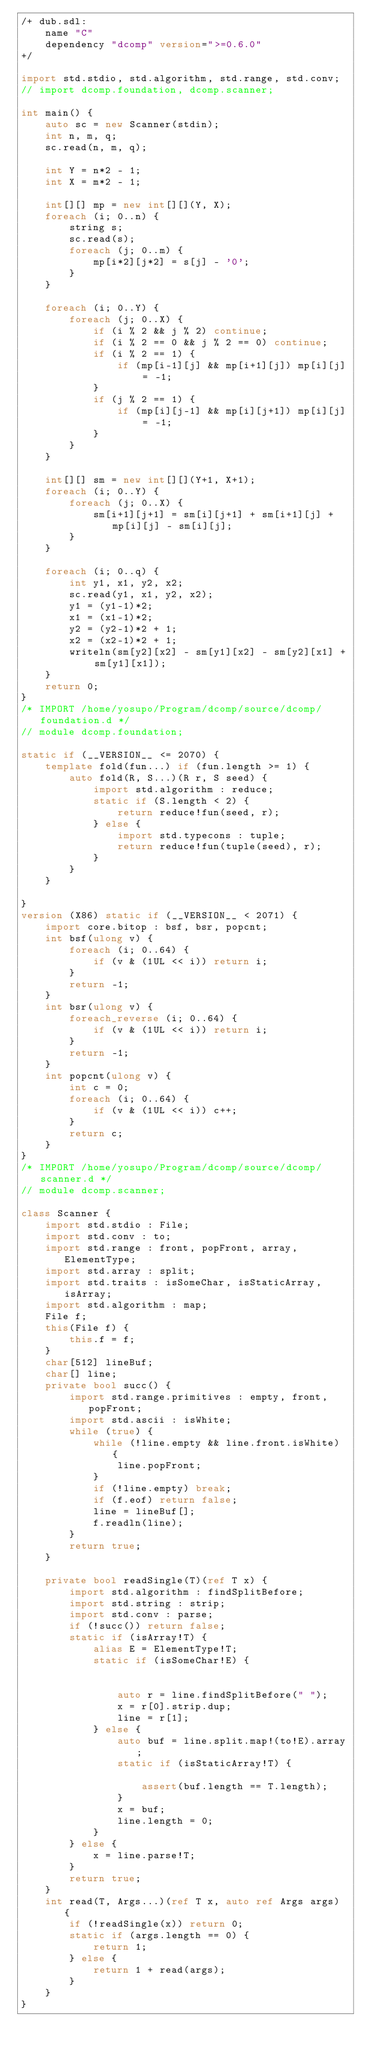<code> <loc_0><loc_0><loc_500><loc_500><_D_>/+ dub.sdl:
    name "C"
    dependency "dcomp" version=">=0.6.0"
+/

import std.stdio, std.algorithm, std.range, std.conv;
// import dcomp.foundation, dcomp.scanner;

int main() {
    auto sc = new Scanner(stdin);
    int n, m, q;
    sc.read(n, m, q);

    int Y = n*2 - 1;
    int X = m*2 - 1;

    int[][] mp = new int[][](Y, X);
    foreach (i; 0..n) {
        string s;
        sc.read(s);
        foreach (j; 0..m) {
            mp[i*2][j*2] = s[j] - '0';
        }
    }

    foreach (i; 0..Y) {
        foreach (j; 0..X) {
            if (i % 2 && j % 2) continue;
            if (i % 2 == 0 && j % 2 == 0) continue;
            if (i % 2 == 1) {
                if (mp[i-1][j] && mp[i+1][j]) mp[i][j] = -1;
            }
            if (j % 2 == 1) {
                if (mp[i][j-1] && mp[i][j+1]) mp[i][j] = -1;
            }
        }
    }

    int[][] sm = new int[][](Y+1, X+1);
    foreach (i; 0..Y) {
        foreach (j; 0..X) {
            sm[i+1][j+1] = sm[i][j+1] + sm[i+1][j] + mp[i][j] - sm[i][j];
        }
    }

    foreach (i; 0..q) {
        int y1, x1, y2, x2;
        sc.read(y1, x1, y2, x2);
        y1 = (y1-1)*2;
        x1 = (x1-1)*2;
        y2 = (y2-1)*2 + 1;
        x2 = (x2-1)*2 + 1;
        writeln(sm[y2][x2] - sm[y1][x2] - sm[y2][x1] + sm[y1][x1]);
    }
    return 0;
}
/* IMPORT /home/yosupo/Program/dcomp/source/dcomp/foundation.d */
// module dcomp.foundation;
 
static if (__VERSION__ <= 2070) {
    template fold(fun...) if (fun.length >= 1) {
        auto fold(R, S...)(R r, S seed) {
            import std.algorithm : reduce;
            static if (S.length < 2) {
                return reduce!fun(seed, r);
            } else {
                import std.typecons : tuple;
                return reduce!fun(tuple(seed), r);
            }
        }
    }
     
}
version (X86) static if (__VERSION__ < 2071) {
    import core.bitop : bsf, bsr, popcnt;
    int bsf(ulong v) {
        foreach (i; 0..64) {
            if (v & (1UL << i)) return i;
        }
        return -1;
    }
    int bsr(ulong v) {
        foreach_reverse (i; 0..64) {
            if (v & (1UL << i)) return i;
        }
        return -1;   
    }
    int popcnt(ulong v) {
        int c = 0;
        foreach (i; 0..64) {
            if (v & (1UL << i)) c++;
        }
        return c;
    }
}
/* IMPORT /home/yosupo/Program/dcomp/source/dcomp/scanner.d */
// module dcomp.scanner;

class Scanner {
    import std.stdio : File;
    import std.conv : to;
    import std.range : front, popFront, array, ElementType;
    import std.array : split;
    import std.traits : isSomeChar, isStaticArray, isArray; 
    import std.algorithm : map;
    File f;
    this(File f) {
        this.f = f;
    }
    char[512] lineBuf;
    char[] line;
    private bool succ() {
        import std.range.primitives : empty, front, popFront;
        import std.ascii : isWhite;
        while (true) {
            while (!line.empty && line.front.isWhite) {
                line.popFront;
            }
            if (!line.empty) break;
            if (f.eof) return false;
            line = lineBuf[];
            f.readln(line);
        }
        return true;
    }

    private bool readSingle(T)(ref T x) {
        import std.algorithm : findSplitBefore;
        import std.string : strip;
        import std.conv : parse;
        if (!succ()) return false;
        static if (isArray!T) {
            alias E = ElementType!T;
            static if (isSomeChar!E) {
                 
                 
                auto r = line.findSplitBefore(" ");
                x = r[0].strip.dup;
                line = r[1];
            } else {
                auto buf = line.split.map!(to!E).array;
                static if (isStaticArray!T) {
                     
                    assert(buf.length == T.length);
                }
                x = buf;
                line.length = 0;
            }
        } else {
            x = line.parse!T;
        }
        return true;
    }
    int read(T, Args...)(ref T x, auto ref Args args) {
        if (!readSingle(x)) return 0;
        static if (args.length == 0) {
            return 1;
        } else {
            return 1 + read(args);
        }
    }
}



 

 
</code> 